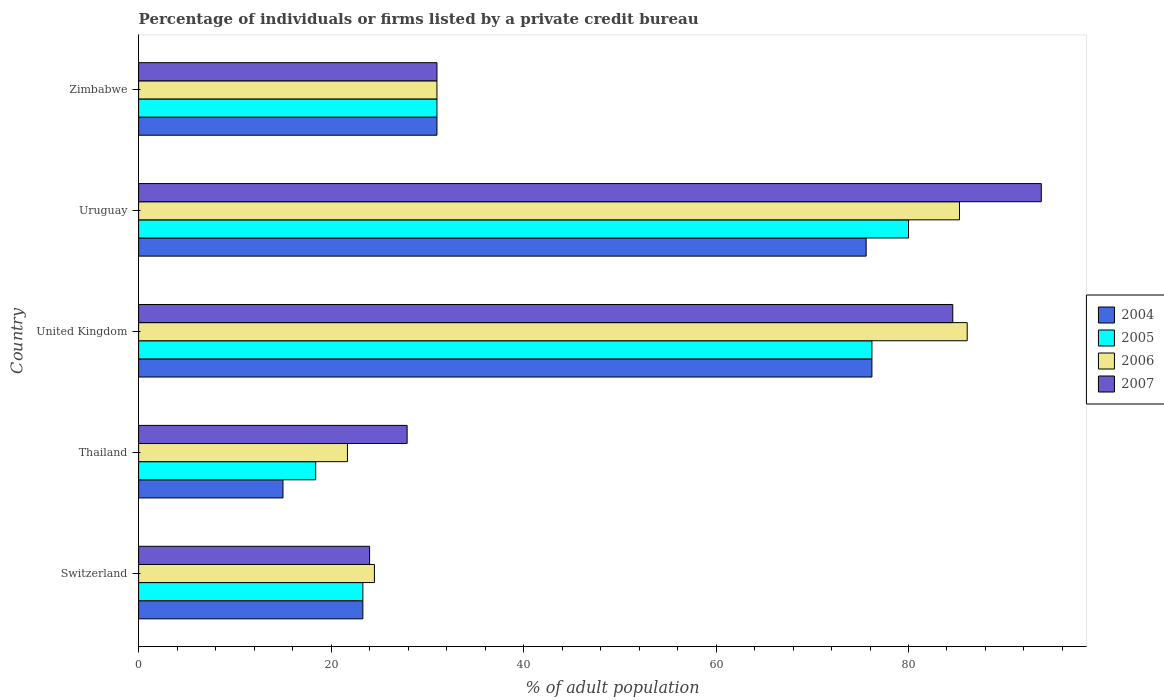How many different coloured bars are there?
Make the answer very short. 4. How many groups of bars are there?
Ensure brevity in your answer.  5. Are the number of bars per tick equal to the number of legend labels?
Keep it short and to the point. Yes. What is the label of the 5th group of bars from the top?
Give a very brief answer. Switzerland. What is the percentage of population listed by a private credit bureau in 2004 in Switzerland?
Make the answer very short. 23.3. Across all countries, what is the minimum percentage of population listed by a private credit bureau in 2004?
Offer a very short reply. 15. In which country was the percentage of population listed by a private credit bureau in 2005 maximum?
Give a very brief answer. Uruguay. In which country was the percentage of population listed by a private credit bureau in 2006 minimum?
Offer a terse response. Thailand. What is the total percentage of population listed by a private credit bureau in 2004 in the graph?
Your answer should be compact. 221.1. What is the difference between the percentage of population listed by a private credit bureau in 2005 in Thailand and that in Zimbabwe?
Offer a very short reply. -12.6. What is the difference between the percentage of population listed by a private credit bureau in 2005 in Zimbabwe and the percentage of population listed by a private credit bureau in 2004 in United Kingdom?
Your response must be concise. -45.2. What is the average percentage of population listed by a private credit bureau in 2006 per country?
Give a very brief answer. 49.72. What is the difference between the percentage of population listed by a private credit bureau in 2004 and percentage of population listed by a private credit bureau in 2007 in Uruguay?
Offer a very short reply. -18.2. What is the ratio of the percentage of population listed by a private credit bureau in 2007 in Thailand to that in Uruguay?
Your answer should be very brief. 0.3. Is the percentage of population listed by a private credit bureau in 2006 in Uruguay less than that in Zimbabwe?
Provide a succinct answer. No. What is the difference between the highest and the second highest percentage of population listed by a private credit bureau in 2007?
Make the answer very short. 9.2. What is the difference between the highest and the lowest percentage of population listed by a private credit bureau in 2007?
Offer a terse response. 69.8. Is the sum of the percentage of population listed by a private credit bureau in 2007 in Switzerland and United Kingdom greater than the maximum percentage of population listed by a private credit bureau in 2005 across all countries?
Your answer should be very brief. Yes. Is it the case that in every country, the sum of the percentage of population listed by a private credit bureau in 2004 and percentage of population listed by a private credit bureau in 2006 is greater than the percentage of population listed by a private credit bureau in 2007?
Keep it short and to the point. Yes. How many countries are there in the graph?
Offer a very short reply. 5. What is the difference between two consecutive major ticks on the X-axis?
Provide a succinct answer. 20. Does the graph contain any zero values?
Give a very brief answer. No. Does the graph contain grids?
Ensure brevity in your answer.  No. Where does the legend appear in the graph?
Ensure brevity in your answer.  Center right. How many legend labels are there?
Your answer should be very brief. 4. What is the title of the graph?
Ensure brevity in your answer.  Percentage of individuals or firms listed by a private credit bureau. Does "1985" appear as one of the legend labels in the graph?
Ensure brevity in your answer.  No. What is the label or title of the X-axis?
Your answer should be compact. % of adult population. What is the label or title of the Y-axis?
Provide a succinct answer. Country. What is the % of adult population in 2004 in Switzerland?
Offer a very short reply. 23.3. What is the % of adult population of 2005 in Switzerland?
Provide a short and direct response. 23.3. What is the % of adult population in 2006 in Switzerland?
Your answer should be very brief. 24.5. What is the % of adult population in 2005 in Thailand?
Provide a succinct answer. 18.4. What is the % of adult population in 2006 in Thailand?
Offer a very short reply. 21.7. What is the % of adult population in 2007 in Thailand?
Make the answer very short. 27.9. What is the % of adult population of 2004 in United Kingdom?
Give a very brief answer. 76.2. What is the % of adult population in 2005 in United Kingdom?
Your answer should be compact. 76.2. What is the % of adult population in 2006 in United Kingdom?
Give a very brief answer. 86.1. What is the % of adult population in 2007 in United Kingdom?
Offer a very short reply. 84.6. What is the % of adult population in 2004 in Uruguay?
Your answer should be very brief. 75.6. What is the % of adult population in 2005 in Uruguay?
Make the answer very short. 80. What is the % of adult population in 2006 in Uruguay?
Your response must be concise. 85.3. What is the % of adult population in 2007 in Uruguay?
Provide a short and direct response. 93.8. What is the % of adult population of 2004 in Zimbabwe?
Ensure brevity in your answer.  31. What is the % of adult population in 2005 in Zimbabwe?
Your answer should be compact. 31. What is the % of adult population in 2007 in Zimbabwe?
Offer a terse response. 31. Across all countries, what is the maximum % of adult population in 2004?
Give a very brief answer. 76.2. Across all countries, what is the maximum % of adult population in 2006?
Provide a succinct answer. 86.1. Across all countries, what is the maximum % of adult population of 2007?
Keep it short and to the point. 93.8. Across all countries, what is the minimum % of adult population in 2005?
Provide a short and direct response. 18.4. Across all countries, what is the minimum % of adult population of 2006?
Provide a succinct answer. 21.7. Across all countries, what is the minimum % of adult population of 2007?
Provide a succinct answer. 24. What is the total % of adult population in 2004 in the graph?
Offer a very short reply. 221.1. What is the total % of adult population in 2005 in the graph?
Give a very brief answer. 228.9. What is the total % of adult population of 2006 in the graph?
Make the answer very short. 248.6. What is the total % of adult population in 2007 in the graph?
Make the answer very short. 261.3. What is the difference between the % of adult population in 2004 in Switzerland and that in United Kingdom?
Your response must be concise. -52.9. What is the difference between the % of adult population in 2005 in Switzerland and that in United Kingdom?
Offer a terse response. -52.9. What is the difference between the % of adult population of 2006 in Switzerland and that in United Kingdom?
Your answer should be very brief. -61.6. What is the difference between the % of adult population of 2007 in Switzerland and that in United Kingdom?
Make the answer very short. -60.6. What is the difference between the % of adult population of 2004 in Switzerland and that in Uruguay?
Your answer should be compact. -52.3. What is the difference between the % of adult population of 2005 in Switzerland and that in Uruguay?
Your answer should be compact. -56.7. What is the difference between the % of adult population of 2006 in Switzerland and that in Uruguay?
Provide a succinct answer. -60.8. What is the difference between the % of adult population in 2007 in Switzerland and that in Uruguay?
Your answer should be compact. -69.8. What is the difference between the % of adult population in 2004 in Switzerland and that in Zimbabwe?
Ensure brevity in your answer.  -7.7. What is the difference between the % of adult population in 2004 in Thailand and that in United Kingdom?
Give a very brief answer. -61.2. What is the difference between the % of adult population in 2005 in Thailand and that in United Kingdom?
Provide a short and direct response. -57.8. What is the difference between the % of adult population of 2006 in Thailand and that in United Kingdom?
Your response must be concise. -64.4. What is the difference between the % of adult population of 2007 in Thailand and that in United Kingdom?
Give a very brief answer. -56.7. What is the difference between the % of adult population of 2004 in Thailand and that in Uruguay?
Offer a very short reply. -60.6. What is the difference between the % of adult population in 2005 in Thailand and that in Uruguay?
Offer a terse response. -61.6. What is the difference between the % of adult population of 2006 in Thailand and that in Uruguay?
Your response must be concise. -63.6. What is the difference between the % of adult population of 2007 in Thailand and that in Uruguay?
Ensure brevity in your answer.  -65.9. What is the difference between the % of adult population in 2004 in Thailand and that in Zimbabwe?
Offer a terse response. -16. What is the difference between the % of adult population in 2006 in Thailand and that in Zimbabwe?
Offer a very short reply. -9.3. What is the difference between the % of adult population of 2007 in Thailand and that in Zimbabwe?
Offer a terse response. -3.1. What is the difference between the % of adult population in 2004 in United Kingdom and that in Uruguay?
Your answer should be compact. 0.6. What is the difference between the % of adult population in 2004 in United Kingdom and that in Zimbabwe?
Your response must be concise. 45.2. What is the difference between the % of adult population in 2005 in United Kingdom and that in Zimbabwe?
Keep it short and to the point. 45.2. What is the difference between the % of adult population of 2006 in United Kingdom and that in Zimbabwe?
Offer a terse response. 55.1. What is the difference between the % of adult population in 2007 in United Kingdom and that in Zimbabwe?
Offer a terse response. 53.6. What is the difference between the % of adult population in 2004 in Uruguay and that in Zimbabwe?
Give a very brief answer. 44.6. What is the difference between the % of adult population of 2006 in Uruguay and that in Zimbabwe?
Your response must be concise. 54.3. What is the difference between the % of adult population in 2007 in Uruguay and that in Zimbabwe?
Keep it short and to the point. 62.8. What is the difference between the % of adult population of 2004 in Switzerland and the % of adult population of 2006 in Thailand?
Your answer should be compact. 1.6. What is the difference between the % of adult population in 2005 in Switzerland and the % of adult population in 2006 in Thailand?
Offer a terse response. 1.6. What is the difference between the % of adult population in 2005 in Switzerland and the % of adult population in 2007 in Thailand?
Ensure brevity in your answer.  -4.6. What is the difference between the % of adult population in 2004 in Switzerland and the % of adult population in 2005 in United Kingdom?
Your response must be concise. -52.9. What is the difference between the % of adult population in 2004 in Switzerland and the % of adult population in 2006 in United Kingdom?
Ensure brevity in your answer.  -62.8. What is the difference between the % of adult population in 2004 in Switzerland and the % of adult population in 2007 in United Kingdom?
Offer a terse response. -61.3. What is the difference between the % of adult population in 2005 in Switzerland and the % of adult population in 2006 in United Kingdom?
Offer a very short reply. -62.8. What is the difference between the % of adult population of 2005 in Switzerland and the % of adult population of 2007 in United Kingdom?
Provide a succinct answer. -61.3. What is the difference between the % of adult population in 2006 in Switzerland and the % of adult population in 2007 in United Kingdom?
Your answer should be very brief. -60.1. What is the difference between the % of adult population of 2004 in Switzerland and the % of adult population of 2005 in Uruguay?
Your answer should be compact. -56.7. What is the difference between the % of adult population of 2004 in Switzerland and the % of adult population of 2006 in Uruguay?
Provide a succinct answer. -62. What is the difference between the % of adult population in 2004 in Switzerland and the % of adult population in 2007 in Uruguay?
Provide a short and direct response. -70.5. What is the difference between the % of adult population in 2005 in Switzerland and the % of adult population in 2006 in Uruguay?
Provide a succinct answer. -62. What is the difference between the % of adult population in 2005 in Switzerland and the % of adult population in 2007 in Uruguay?
Provide a succinct answer. -70.5. What is the difference between the % of adult population of 2006 in Switzerland and the % of adult population of 2007 in Uruguay?
Make the answer very short. -69.3. What is the difference between the % of adult population in 2004 in Switzerland and the % of adult population in 2007 in Zimbabwe?
Give a very brief answer. -7.7. What is the difference between the % of adult population in 2005 in Switzerland and the % of adult population in 2006 in Zimbabwe?
Offer a terse response. -7.7. What is the difference between the % of adult population of 2006 in Switzerland and the % of adult population of 2007 in Zimbabwe?
Your answer should be compact. -6.5. What is the difference between the % of adult population in 2004 in Thailand and the % of adult population in 2005 in United Kingdom?
Your answer should be very brief. -61.2. What is the difference between the % of adult population in 2004 in Thailand and the % of adult population in 2006 in United Kingdom?
Your answer should be compact. -71.1. What is the difference between the % of adult population of 2004 in Thailand and the % of adult population of 2007 in United Kingdom?
Make the answer very short. -69.6. What is the difference between the % of adult population of 2005 in Thailand and the % of adult population of 2006 in United Kingdom?
Keep it short and to the point. -67.7. What is the difference between the % of adult population of 2005 in Thailand and the % of adult population of 2007 in United Kingdom?
Provide a short and direct response. -66.2. What is the difference between the % of adult population in 2006 in Thailand and the % of adult population in 2007 in United Kingdom?
Your answer should be compact. -62.9. What is the difference between the % of adult population of 2004 in Thailand and the % of adult population of 2005 in Uruguay?
Ensure brevity in your answer.  -65. What is the difference between the % of adult population of 2004 in Thailand and the % of adult population of 2006 in Uruguay?
Offer a very short reply. -70.3. What is the difference between the % of adult population in 2004 in Thailand and the % of adult population in 2007 in Uruguay?
Keep it short and to the point. -78.8. What is the difference between the % of adult population of 2005 in Thailand and the % of adult population of 2006 in Uruguay?
Offer a very short reply. -66.9. What is the difference between the % of adult population of 2005 in Thailand and the % of adult population of 2007 in Uruguay?
Make the answer very short. -75.4. What is the difference between the % of adult population in 2006 in Thailand and the % of adult population in 2007 in Uruguay?
Provide a short and direct response. -72.1. What is the difference between the % of adult population in 2004 in Thailand and the % of adult population in 2005 in Zimbabwe?
Your answer should be very brief. -16. What is the difference between the % of adult population in 2004 in Thailand and the % of adult population in 2006 in Zimbabwe?
Offer a very short reply. -16. What is the difference between the % of adult population of 2004 in Thailand and the % of adult population of 2007 in Zimbabwe?
Make the answer very short. -16. What is the difference between the % of adult population of 2005 in Thailand and the % of adult population of 2006 in Zimbabwe?
Your answer should be very brief. -12.6. What is the difference between the % of adult population in 2006 in Thailand and the % of adult population in 2007 in Zimbabwe?
Make the answer very short. -9.3. What is the difference between the % of adult population of 2004 in United Kingdom and the % of adult population of 2005 in Uruguay?
Your answer should be very brief. -3.8. What is the difference between the % of adult population of 2004 in United Kingdom and the % of adult population of 2007 in Uruguay?
Provide a short and direct response. -17.6. What is the difference between the % of adult population in 2005 in United Kingdom and the % of adult population in 2007 in Uruguay?
Provide a succinct answer. -17.6. What is the difference between the % of adult population in 2004 in United Kingdom and the % of adult population in 2005 in Zimbabwe?
Your answer should be compact. 45.2. What is the difference between the % of adult population of 2004 in United Kingdom and the % of adult population of 2006 in Zimbabwe?
Offer a very short reply. 45.2. What is the difference between the % of adult population of 2004 in United Kingdom and the % of adult population of 2007 in Zimbabwe?
Make the answer very short. 45.2. What is the difference between the % of adult population in 2005 in United Kingdom and the % of adult population in 2006 in Zimbabwe?
Give a very brief answer. 45.2. What is the difference between the % of adult population in 2005 in United Kingdom and the % of adult population in 2007 in Zimbabwe?
Provide a short and direct response. 45.2. What is the difference between the % of adult population in 2006 in United Kingdom and the % of adult population in 2007 in Zimbabwe?
Provide a short and direct response. 55.1. What is the difference between the % of adult population of 2004 in Uruguay and the % of adult population of 2005 in Zimbabwe?
Your answer should be very brief. 44.6. What is the difference between the % of adult population in 2004 in Uruguay and the % of adult population in 2006 in Zimbabwe?
Provide a succinct answer. 44.6. What is the difference between the % of adult population of 2004 in Uruguay and the % of adult population of 2007 in Zimbabwe?
Offer a terse response. 44.6. What is the difference between the % of adult population in 2005 in Uruguay and the % of adult population in 2006 in Zimbabwe?
Keep it short and to the point. 49. What is the difference between the % of adult population of 2005 in Uruguay and the % of adult population of 2007 in Zimbabwe?
Your response must be concise. 49. What is the difference between the % of adult population of 2006 in Uruguay and the % of adult population of 2007 in Zimbabwe?
Ensure brevity in your answer.  54.3. What is the average % of adult population in 2004 per country?
Ensure brevity in your answer.  44.22. What is the average % of adult population in 2005 per country?
Offer a terse response. 45.78. What is the average % of adult population in 2006 per country?
Your response must be concise. 49.72. What is the average % of adult population of 2007 per country?
Keep it short and to the point. 52.26. What is the difference between the % of adult population in 2004 and % of adult population in 2006 in Switzerland?
Your answer should be compact. -1.2. What is the difference between the % of adult population of 2004 and % of adult population of 2007 in Switzerland?
Your answer should be compact. -0.7. What is the difference between the % of adult population of 2005 and % of adult population of 2007 in Switzerland?
Offer a terse response. -0.7. What is the difference between the % of adult population in 2006 and % of adult population in 2007 in Switzerland?
Provide a short and direct response. 0.5. What is the difference between the % of adult population in 2004 and % of adult population in 2007 in Thailand?
Make the answer very short. -12.9. What is the difference between the % of adult population in 2005 and % of adult population in 2006 in Thailand?
Give a very brief answer. -3.3. What is the difference between the % of adult population in 2004 and % of adult population in 2007 in United Kingdom?
Offer a very short reply. -8.4. What is the difference between the % of adult population of 2005 and % of adult population of 2006 in United Kingdom?
Offer a terse response. -9.9. What is the difference between the % of adult population of 2004 and % of adult population of 2006 in Uruguay?
Offer a very short reply. -9.7. What is the difference between the % of adult population in 2004 and % of adult population in 2007 in Uruguay?
Your answer should be very brief. -18.2. What is the difference between the % of adult population of 2004 and % of adult population of 2007 in Zimbabwe?
Offer a terse response. 0. What is the difference between the % of adult population of 2005 and % of adult population of 2006 in Zimbabwe?
Your answer should be compact. 0. What is the difference between the % of adult population in 2005 and % of adult population in 2007 in Zimbabwe?
Your response must be concise. 0. What is the difference between the % of adult population of 2006 and % of adult population of 2007 in Zimbabwe?
Give a very brief answer. 0. What is the ratio of the % of adult population in 2004 in Switzerland to that in Thailand?
Offer a very short reply. 1.55. What is the ratio of the % of adult population in 2005 in Switzerland to that in Thailand?
Provide a short and direct response. 1.27. What is the ratio of the % of adult population of 2006 in Switzerland to that in Thailand?
Your answer should be compact. 1.13. What is the ratio of the % of adult population of 2007 in Switzerland to that in Thailand?
Ensure brevity in your answer.  0.86. What is the ratio of the % of adult population in 2004 in Switzerland to that in United Kingdom?
Provide a short and direct response. 0.31. What is the ratio of the % of adult population of 2005 in Switzerland to that in United Kingdom?
Offer a very short reply. 0.31. What is the ratio of the % of adult population of 2006 in Switzerland to that in United Kingdom?
Keep it short and to the point. 0.28. What is the ratio of the % of adult population of 2007 in Switzerland to that in United Kingdom?
Make the answer very short. 0.28. What is the ratio of the % of adult population in 2004 in Switzerland to that in Uruguay?
Make the answer very short. 0.31. What is the ratio of the % of adult population in 2005 in Switzerland to that in Uruguay?
Make the answer very short. 0.29. What is the ratio of the % of adult population of 2006 in Switzerland to that in Uruguay?
Your answer should be very brief. 0.29. What is the ratio of the % of adult population in 2007 in Switzerland to that in Uruguay?
Offer a very short reply. 0.26. What is the ratio of the % of adult population in 2004 in Switzerland to that in Zimbabwe?
Offer a terse response. 0.75. What is the ratio of the % of adult population in 2005 in Switzerland to that in Zimbabwe?
Offer a terse response. 0.75. What is the ratio of the % of adult population in 2006 in Switzerland to that in Zimbabwe?
Your answer should be compact. 0.79. What is the ratio of the % of adult population in 2007 in Switzerland to that in Zimbabwe?
Provide a succinct answer. 0.77. What is the ratio of the % of adult population in 2004 in Thailand to that in United Kingdom?
Provide a short and direct response. 0.2. What is the ratio of the % of adult population of 2005 in Thailand to that in United Kingdom?
Give a very brief answer. 0.24. What is the ratio of the % of adult population in 2006 in Thailand to that in United Kingdom?
Offer a terse response. 0.25. What is the ratio of the % of adult population of 2007 in Thailand to that in United Kingdom?
Ensure brevity in your answer.  0.33. What is the ratio of the % of adult population in 2004 in Thailand to that in Uruguay?
Make the answer very short. 0.2. What is the ratio of the % of adult population in 2005 in Thailand to that in Uruguay?
Ensure brevity in your answer.  0.23. What is the ratio of the % of adult population of 2006 in Thailand to that in Uruguay?
Provide a succinct answer. 0.25. What is the ratio of the % of adult population of 2007 in Thailand to that in Uruguay?
Keep it short and to the point. 0.3. What is the ratio of the % of adult population of 2004 in Thailand to that in Zimbabwe?
Provide a succinct answer. 0.48. What is the ratio of the % of adult population of 2005 in Thailand to that in Zimbabwe?
Provide a succinct answer. 0.59. What is the ratio of the % of adult population in 2007 in Thailand to that in Zimbabwe?
Your answer should be very brief. 0.9. What is the ratio of the % of adult population in 2004 in United Kingdom to that in Uruguay?
Ensure brevity in your answer.  1.01. What is the ratio of the % of adult population of 2005 in United Kingdom to that in Uruguay?
Give a very brief answer. 0.95. What is the ratio of the % of adult population in 2006 in United Kingdom to that in Uruguay?
Your answer should be very brief. 1.01. What is the ratio of the % of adult population of 2007 in United Kingdom to that in Uruguay?
Your answer should be very brief. 0.9. What is the ratio of the % of adult population in 2004 in United Kingdom to that in Zimbabwe?
Your response must be concise. 2.46. What is the ratio of the % of adult population of 2005 in United Kingdom to that in Zimbabwe?
Offer a terse response. 2.46. What is the ratio of the % of adult population in 2006 in United Kingdom to that in Zimbabwe?
Your answer should be compact. 2.78. What is the ratio of the % of adult population of 2007 in United Kingdom to that in Zimbabwe?
Give a very brief answer. 2.73. What is the ratio of the % of adult population in 2004 in Uruguay to that in Zimbabwe?
Your answer should be compact. 2.44. What is the ratio of the % of adult population in 2005 in Uruguay to that in Zimbabwe?
Your answer should be compact. 2.58. What is the ratio of the % of adult population of 2006 in Uruguay to that in Zimbabwe?
Provide a succinct answer. 2.75. What is the ratio of the % of adult population of 2007 in Uruguay to that in Zimbabwe?
Provide a short and direct response. 3.03. What is the difference between the highest and the second highest % of adult population of 2004?
Ensure brevity in your answer.  0.6. What is the difference between the highest and the second highest % of adult population of 2006?
Provide a short and direct response. 0.8. What is the difference between the highest and the lowest % of adult population of 2004?
Provide a short and direct response. 61.2. What is the difference between the highest and the lowest % of adult population in 2005?
Keep it short and to the point. 61.6. What is the difference between the highest and the lowest % of adult population in 2006?
Provide a succinct answer. 64.4. What is the difference between the highest and the lowest % of adult population in 2007?
Provide a succinct answer. 69.8. 